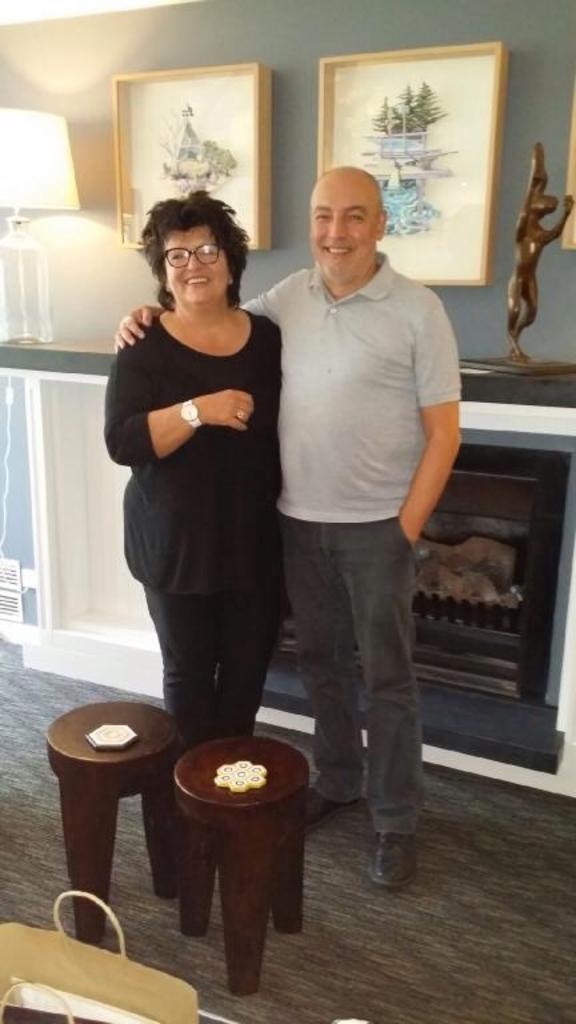Can you describe this image briefly? There are two people standing and holding each other and there is a table in front of them which has some objects on it and there are pictures attached to the wall in the background. 